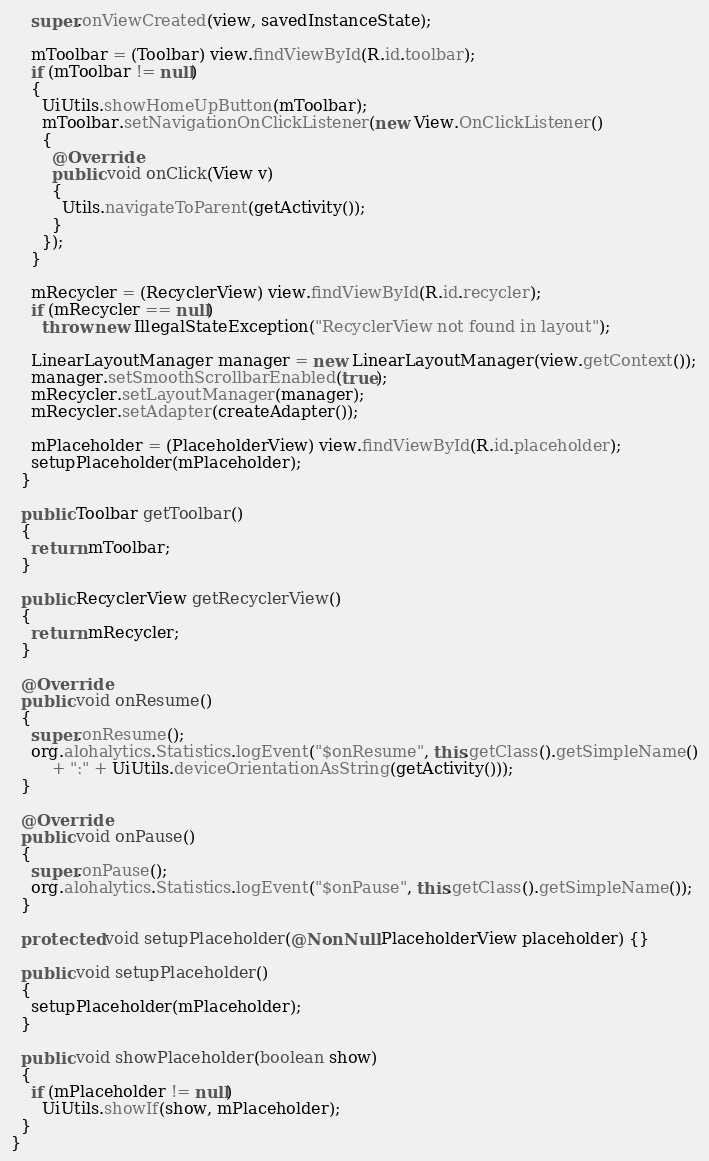Convert code to text. <code><loc_0><loc_0><loc_500><loc_500><_Java_>    super.onViewCreated(view, savedInstanceState);

    mToolbar = (Toolbar) view.findViewById(R.id.toolbar);
    if (mToolbar != null)
    {
      UiUtils.showHomeUpButton(mToolbar);
      mToolbar.setNavigationOnClickListener(new View.OnClickListener()
      {
        @Override
        public void onClick(View v)
        {
          Utils.navigateToParent(getActivity());
        }
      });
    }

    mRecycler = (RecyclerView) view.findViewById(R.id.recycler);
    if (mRecycler == null)
      throw new IllegalStateException("RecyclerView not found in layout");

    LinearLayoutManager manager = new LinearLayoutManager(view.getContext());
    manager.setSmoothScrollbarEnabled(true);
    mRecycler.setLayoutManager(manager);
    mRecycler.setAdapter(createAdapter());

    mPlaceholder = (PlaceholderView) view.findViewById(R.id.placeholder);
    setupPlaceholder(mPlaceholder);
  }

  public Toolbar getToolbar()
  {
    return mToolbar;
  }

  public RecyclerView getRecyclerView()
  {
    return mRecycler;
  }

  @Override
  public void onResume()
  {
    super.onResume();
    org.alohalytics.Statistics.logEvent("$onResume", this.getClass().getSimpleName()
        + ":" + UiUtils.deviceOrientationAsString(getActivity()));
  }

  @Override
  public void onPause()
  {
    super.onPause();
    org.alohalytics.Statistics.logEvent("$onPause", this.getClass().getSimpleName());
  }

  protected void setupPlaceholder(@NonNull PlaceholderView placeholder) {}

  public void setupPlaceholder()
  {
    setupPlaceholder(mPlaceholder);
  }

  public void showPlaceholder(boolean show)
  {
    if (mPlaceholder != null)
      UiUtils.showIf(show, mPlaceholder);
  }
}
</code> 